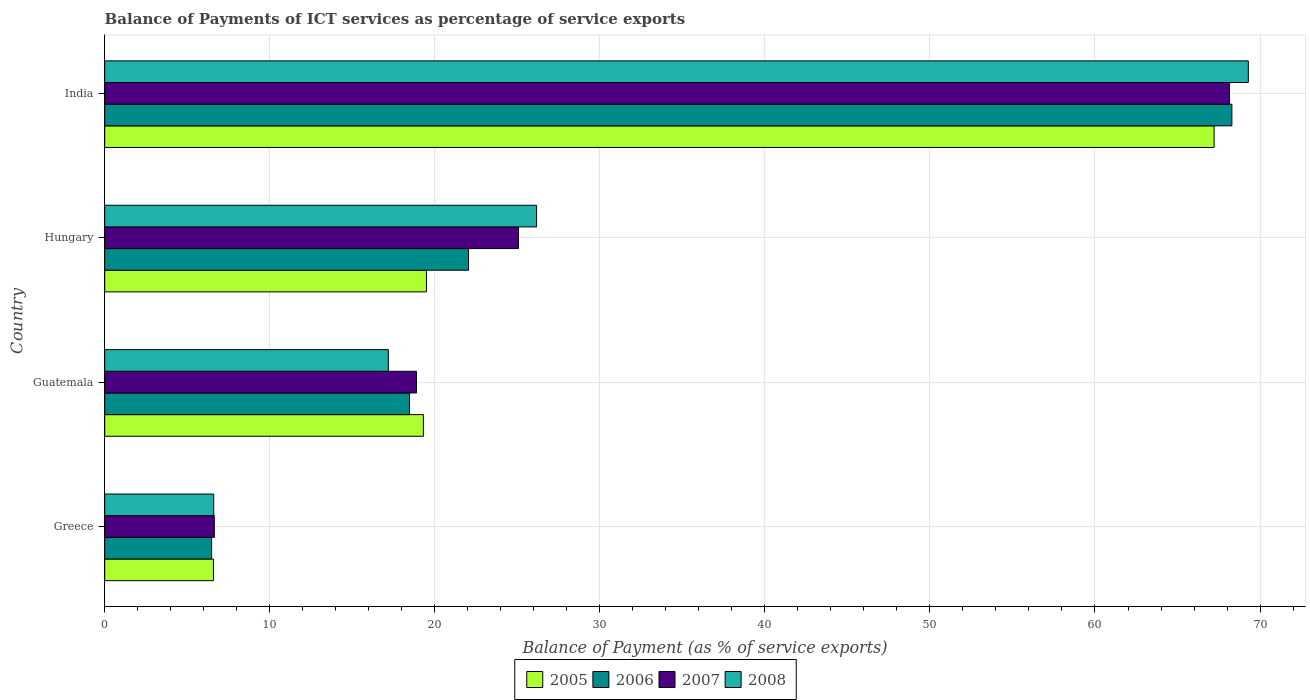How many different coloured bars are there?
Your answer should be very brief. 4. How many groups of bars are there?
Give a very brief answer. 4. Are the number of bars on each tick of the Y-axis equal?
Offer a terse response. Yes. How many bars are there on the 1st tick from the bottom?
Provide a short and direct response. 4. What is the label of the 2nd group of bars from the top?
Offer a terse response. Hungary. In how many cases, is the number of bars for a given country not equal to the number of legend labels?
Offer a terse response. 0. What is the balance of payments of ICT services in 2006 in India?
Give a very brief answer. 68.29. Across all countries, what is the maximum balance of payments of ICT services in 2005?
Offer a very short reply. 67.22. Across all countries, what is the minimum balance of payments of ICT services in 2005?
Keep it short and to the point. 6.59. In which country was the balance of payments of ICT services in 2005 maximum?
Provide a short and direct response. India. In which country was the balance of payments of ICT services in 2007 minimum?
Provide a succinct answer. Greece. What is the total balance of payments of ICT services in 2008 in the graph?
Offer a terse response. 119.24. What is the difference between the balance of payments of ICT services in 2008 in Guatemala and that in Hungary?
Give a very brief answer. -8.98. What is the difference between the balance of payments of ICT services in 2008 in India and the balance of payments of ICT services in 2007 in Hungary?
Your answer should be very brief. 44.22. What is the average balance of payments of ICT services in 2005 per country?
Your answer should be compact. 28.15. What is the difference between the balance of payments of ICT services in 2008 and balance of payments of ICT services in 2006 in Greece?
Your response must be concise. 0.13. In how many countries, is the balance of payments of ICT services in 2005 greater than 12 %?
Provide a succinct answer. 3. What is the ratio of the balance of payments of ICT services in 2007 in Greece to that in Guatemala?
Your response must be concise. 0.35. Is the balance of payments of ICT services in 2008 in Greece less than that in Hungary?
Your answer should be very brief. Yes. Is the difference between the balance of payments of ICT services in 2008 in Greece and Guatemala greater than the difference between the balance of payments of ICT services in 2006 in Greece and Guatemala?
Your response must be concise. Yes. What is the difference between the highest and the second highest balance of payments of ICT services in 2008?
Your answer should be very brief. 43.12. What is the difference between the highest and the lowest balance of payments of ICT services in 2008?
Ensure brevity in your answer.  62.69. Is it the case that in every country, the sum of the balance of payments of ICT services in 2007 and balance of payments of ICT services in 2006 is greater than the sum of balance of payments of ICT services in 2008 and balance of payments of ICT services in 2005?
Provide a short and direct response. No. What does the 4th bar from the bottom in Greece represents?
Your answer should be compact. 2008. Is it the case that in every country, the sum of the balance of payments of ICT services in 2006 and balance of payments of ICT services in 2008 is greater than the balance of payments of ICT services in 2005?
Your answer should be compact. Yes. How many countries are there in the graph?
Your response must be concise. 4. Are the values on the major ticks of X-axis written in scientific E-notation?
Offer a very short reply. No. Does the graph contain grids?
Offer a terse response. Yes. How are the legend labels stacked?
Ensure brevity in your answer.  Horizontal. What is the title of the graph?
Give a very brief answer. Balance of Payments of ICT services as percentage of service exports. What is the label or title of the X-axis?
Your answer should be compact. Balance of Payment (as % of service exports). What is the label or title of the Y-axis?
Keep it short and to the point. Country. What is the Balance of Payment (as % of service exports) in 2005 in Greece?
Give a very brief answer. 6.59. What is the Balance of Payment (as % of service exports) of 2006 in Greece?
Give a very brief answer. 6.48. What is the Balance of Payment (as % of service exports) of 2007 in Greece?
Ensure brevity in your answer.  6.64. What is the Balance of Payment (as % of service exports) in 2008 in Greece?
Provide a short and direct response. 6.6. What is the Balance of Payment (as % of service exports) in 2005 in Guatemala?
Provide a short and direct response. 19.31. What is the Balance of Payment (as % of service exports) in 2006 in Guatemala?
Your response must be concise. 18.47. What is the Balance of Payment (as % of service exports) of 2007 in Guatemala?
Make the answer very short. 18.89. What is the Balance of Payment (as % of service exports) of 2008 in Guatemala?
Offer a terse response. 17.18. What is the Balance of Payment (as % of service exports) of 2005 in Hungary?
Your response must be concise. 19.5. What is the Balance of Payment (as % of service exports) in 2006 in Hungary?
Ensure brevity in your answer.  22.04. What is the Balance of Payment (as % of service exports) in 2007 in Hungary?
Keep it short and to the point. 25.07. What is the Balance of Payment (as % of service exports) in 2008 in Hungary?
Keep it short and to the point. 26.17. What is the Balance of Payment (as % of service exports) of 2005 in India?
Provide a short and direct response. 67.22. What is the Balance of Payment (as % of service exports) of 2006 in India?
Your answer should be very brief. 68.29. What is the Balance of Payment (as % of service exports) of 2007 in India?
Give a very brief answer. 68.15. What is the Balance of Payment (as % of service exports) in 2008 in India?
Your answer should be very brief. 69.29. Across all countries, what is the maximum Balance of Payment (as % of service exports) in 2005?
Your answer should be very brief. 67.22. Across all countries, what is the maximum Balance of Payment (as % of service exports) in 2006?
Provide a succinct answer. 68.29. Across all countries, what is the maximum Balance of Payment (as % of service exports) in 2007?
Give a very brief answer. 68.15. Across all countries, what is the maximum Balance of Payment (as % of service exports) of 2008?
Offer a terse response. 69.29. Across all countries, what is the minimum Balance of Payment (as % of service exports) of 2005?
Give a very brief answer. 6.59. Across all countries, what is the minimum Balance of Payment (as % of service exports) of 2006?
Offer a terse response. 6.48. Across all countries, what is the minimum Balance of Payment (as % of service exports) in 2007?
Give a very brief answer. 6.64. Across all countries, what is the minimum Balance of Payment (as % of service exports) in 2008?
Provide a succinct answer. 6.6. What is the total Balance of Payment (as % of service exports) of 2005 in the graph?
Offer a very short reply. 112.61. What is the total Balance of Payment (as % of service exports) of 2006 in the graph?
Your response must be concise. 115.28. What is the total Balance of Payment (as % of service exports) in 2007 in the graph?
Your answer should be very brief. 118.75. What is the total Balance of Payment (as % of service exports) in 2008 in the graph?
Make the answer very short. 119.24. What is the difference between the Balance of Payment (as % of service exports) in 2005 in Greece and that in Guatemala?
Offer a very short reply. -12.72. What is the difference between the Balance of Payment (as % of service exports) in 2006 in Greece and that in Guatemala?
Provide a short and direct response. -11.99. What is the difference between the Balance of Payment (as % of service exports) in 2007 in Greece and that in Guatemala?
Your response must be concise. -12.25. What is the difference between the Balance of Payment (as % of service exports) in 2008 in Greece and that in Guatemala?
Your answer should be very brief. -10.58. What is the difference between the Balance of Payment (as % of service exports) in 2005 in Greece and that in Hungary?
Your response must be concise. -12.91. What is the difference between the Balance of Payment (as % of service exports) in 2006 in Greece and that in Hungary?
Make the answer very short. -15.57. What is the difference between the Balance of Payment (as % of service exports) in 2007 in Greece and that in Hungary?
Provide a succinct answer. -18.43. What is the difference between the Balance of Payment (as % of service exports) of 2008 in Greece and that in Hungary?
Your answer should be compact. -19.56. What is the difference between the Balance of Payment (as % of service exports) in 2005 in Greece and that in India?
Give a very brief answer. -60.63. What is the difference between the Balance of Payment (as % of service exports) of 2006 in Greece and that in India?
Make the answer very short. -61.82. What is the difference between the Balance of Payment (as % of service exports) of 2007 in Greece and that in India?
Your answer should be compact. -61.51. What is the difference between the Balance of Payment (as % of service exports) in 2008 in Greece and that in India?
Your response must be concise. -62.69. What is the difference between the Balance of Payment (as % of service exports) in 2005 in Guatemala and that in Hungary?
Keep it short and to the point. -0.19. What is the difference between the Balance of Payment (as % of service exports) of 2006 in Guatemala and that in Hungary?
Your answer should be very brief. -3.57. What is the difference between the Balance of Payment (as % of service exports) in 2007 in Guatemala and that in Hungary?
Offer a very short reply. -6.18. What is the difference between the Balance of Payment (as % of service exports) in 2008 in Guatemala and that in Hungary?
Offer a terse response. -8.98. What is the difference between the Balance of Payment (as % of service exports) of 2005 in Guatemala and that in India?
Your answer should be very brief. -47.91. What is the difference between the Balance of Payment (as % of service exports) in 2006 in Guatemala and that in India?
Make the answer very short. -49.83. What is the difference between the Balance of Payment (as % of service exports) of 2007 in Guatemala and that in India?
Your response must be concise. -49.26. What is the difference between the Balance of Payment (as % of service exports) of 2008 in Guatemala and that in India?
Make the answer very short. -52.11. What is the difference between the Balance of Payment (as % of service exports) of 2005 in Hungary and that in India?
Offer a very short reply. -47.72. What is the difference between the Balance of Payment (as % of service exports) of 2006 in Hungary and that in India?
Offer a very short reply. -46.25. What is the difference between the Balance of Payment (as % of service exports) of 2007 in Hungary and that in India?
Offer a very short reply. -43.08. What is the difference between the Balance of Payment (as % of service exports) in 2008 in Hungary and that in India?
Your answer should be compact. -43.12. What is the difference between the Balance of Payment (as % of service exports) in 2005 in Greece and the Balance of Payment (as % of service exports) in 2006 in Guatemala?
Provide a short and direct response. -11.88. What is the difference between the Balance of Payment (as % of service exports) of 2005 in Greece and the Balance of Payment (as % of service exports) of 2007 in Guatemala?
Provide a succinct answer. -12.3. What is the difference between the Balance of Payment (as % of service exports) in 2005 in Greece and the Balance of Payment (as % of service exports) in 2008 in Guatemala?
Provide a succinct answer. -10.6. What is the difference between the Balance of Payment (as % of service exports) in 2006 in Greece and the Balance of Payment (as % of service exports) in 2007 in Guatemala?
Provide a succinct answer. -12.41. What is the difference between the Balance of Payment (as % of service exports) of 2006 in Greece and the Balance of Payment (as % of service exports) of 2008 in Guatemala?
Keep it short and to the point. -10.71. What is the difference between the Balance of Payment (as % of service exports) of 2007 in Greece and the Balance of Payment (as % of service exports) of 2008 in Guatemala?
Your answer should be compact. -10.54. What is the difference between the Balance of Payment (as % of service exports) in 2005 in Greece and the Balance of Payment (as % of service exports) in 2006 in Hungary?
Your answer should be compact. -15.45. What is the difference between the Balance of Payment (as % of service exports) in 2005 in Greece and the Balance of Payment (as % of service exports) in 2007 in Hungary?
Give a very brief answer. -18.48. What is the difference between the Balance of Payment (as % of service exports) in 2005 in Greece and the Balance of Payment (as % of service exports) in 2008 in Hungary?
Your answer should be compact. -19.58. What is the difference between the Balance of Payment (as % of service exports) in 2006 in Greece and the Balance of Payment (as % of service exports) in 2007 in Hungary?
Give a very brief answer. -18.59. What is the difference between the Balance of Payment (as % of service exports) in 2006 in Greece and the Balance of Payment (as % of service exports) in 2008 in Hungary?
Your answer should be very brief. -19.69. What is the difference between the Balance of Payment (as % of service exports) in 2007 in Greece and the Balance of Payment (as % of service exports) in 2008 in Hungary?
Offer a terse response. -19.53. What is the difference between the Balance of Payment (as % of service exports) of 2005 in Greece and the Balance of Payment (as % of service exports) of 2006 in India?
Ensure brevity in your answer.  -61.71. What is the difference between the Balance of Payment (as % of service exports) in 2005 in Greece and the Balance of Payment (as % of service exports) in 2007 in India?
Offer a terse response. -61.56. What is the difference between the Balance of Payment (as % of service exports) in 2005 in Greece and the Balance of Payment (as % of service exports) in 2008 in India?
Ensure brevity in your answer.  -62.7. What is the difference between the Balance of Payment (as % of service exports) in 2006 in Greece and the Balance of Payment (as % of service exports) in 2007 in India?
Offer a terse response. -61.67. What is the difference between the Balance of Payment (as % of service exports) of 2006 in Greece and the Balance of Payment (as % of service exports) of 2008 in India?
Make the answer very short. -62.81. What is the difference between the Balance of Payment (as % of service exports) of 2007 in Greece and the Balance of Payment (as % of service exports) of 2008 in India?
Your answer should be compact. -62.65. What is the difference between the Balance of Payment (as % of service exports) of 2005 in Guatemala and the Balance of Payment (as % of service exports) of 2006 in Hungary?
Give a very brief answer. -2.73. What is the difference between the Balance of Payment (as % of service exports) of 2005 in Guatemala and the Balance of Payment (as % of service exports) of 2007 in Hungary?
Provide a succinct answer. -5.76. What is the difference between the Balance of Payment (as % of service exports) in 2005 in Guatemala and the Balance of Payment (as % of service exports) in 2008 in Hungary?
Provide a succinct answer. -6.86. What is the difference between the Balance of Payment (as % of service exports) of 2006 in Guatemala and the Balance of Payment (as % of service exports) of 2007 in Hungary?
Keep it short and to the point. -6.6. What is the difference between the Balance of Payment (as % of service exports) of 2006 in Guatemala and the Balance of Payment (as % of service exports) of 2008 in Hungary?
Your response must be concise. -7.7. What is the difference between the Balance of Payment (as % of service exports) in 2007 in Guatemala and the Balance of Payment (as % of service exports) in 2008 in Hungary?
Your response must be concise. -7.28. What is the difference between the Balance of Payment (as % of service exports) of 2005 in Guatemala and the Balance of Payment (as % of service exports) of 2006 in India?
Offer a very short reply. -48.99. What is the difference between the Balance of Payment (as % of service exports) of 2005 in Guatemala and the Balance of Payment (as % of service exports) of 2007 in India?
Ensure brevity in your answer.  -48.84. What is the difference between the Balance of Payment (as % of service exports) of 2005 in Guatemala and the Balance of Payment (as % of service exports) of 2008 in India?
Keep it short and to the point. -49.98. What is the difference between the Balance of Payment (as % of service exports) in 2006 in Guatemala and the Balance of Payment (as % of service exports) in 2007 in India?
Make the answer very short. -49.68. What is the difference between the Balance of Payment (as % of service exports) of 2006 in Guatemala and the Balance of Payment (as % of service exports) of 2008 in India?
Provide a succinct answer. -50.82. What is the difference between the Balance of Payment (as % of service exports) in 2007 in Guatemala and the Balance of Payment (as % of service exports) in 2008 in India?
Make the answer very short. -50.4. What is the difference between the Balance of Payment (as % of service exports) in 2005 in Hungary and the Balance of Payment (as % of service exports) in 2006 in India?
Your answer should be compact. -48.8. What is the difference between the Balance of Payment (as % of service exports) of 2005 in Hungary and the Balance of Payment (as % of service exports) of 2007 in India?
Provide a succinct answer. -48.65. What is the difference between the Balance of Payment (as % of service exports) in 2005 in Hungary and the Balance of Payment (as % of service exports) in 2008 in India?
Make the answer very short. -49.79. What is the difference between the Balance of Payment (as % of service exports) in 2006 in Hungary and the Balance of Payment (as % of service exports) in 2007 in India?
Your answer should be very brief. -46.11. What is the difference between the Balance of Payment (as % of service exports) in 2006 in Hungary and the Balance of Payment (as % of service exports) in 2008 in India?
Offer a very short reply. -47.25. What is the difference between the Balance of Payment (as % of service exports) in 2007 in Hungary and the Balance of Payment (as % of service exports) in 2008 in India?
Keep it short and to the point. -44.22. What is the average Balance of Payment (as % of service exports) in 2005 per country?
Your answer should be compact. 28.15. What is the average Balance of Payment (as % of service exports) in 2006 per country?
Ensure brevity in your answer.  28.82. What is the average Balance of Payment (as % of service exports) of 2007 per country?
Make the answer very short. 29.69. What is the average Balance of Payment (as % of service exports) in 2008 per country?
Keep it short and to the point. 29.81. What is the difference between the Balance of Payment (as % of service exports) of 2005 and Balance of Payment (as % of service exports) of 2006 in Greece?
Ensure brevity in your answer.  0.11. What is the difference between the Balance of Payment (as % of service exports) of 2005 and Balance of Payment (as % of service exports) of 2007 in Greece?
Make the answer very short. -0.05. What is the difference between the Balance of Payment (as % of service exports) in 2005 and Balance of Payment (as % of service exports) in 2008 in Greece?
Ensure brevity in your answer.  -0.02. What is the difference between the Balance of Payment (as % of service exports) in 2006 and Balance of Payment (as % of service exports) in 2007 in Greece?
Offer a terse response. -0.16. What is the difference between the Balance of Payment (as % of service exports) in 2006 and Balance of Payment (as % of service exports) in 2008 in Greece?
Make the answer very short. -0.13. What is the difference between the Balance of Payment (as % of service exports) in 2007 and Balance of Payment (as % of service exports) in 2008 in Greece?
Provide a short and direct response. 0.04. What is the difference between the Balance of Payment (as % of service exports) in 2005 and Balance of Payment (as % of service exports) in 2006 in Guatemala?
Keep it short and to the point. 0.84. What is the difference between the Balance of Payment (as % of service exports) in 2005 and Balance of Payment (as % of service exports) in 2007 in Guatemala?
Your answer should be very brief. 0.42. What is the difference between the Balance of Payment (as % of service exports) in 2005 and Balance of Payment (as % of service exports) in 2008 in Guatemala?
Make the answer very short. 2.12. What is the difference between the Balance of Payment (as % of service exports) of 2006 and Balance of Payment (as % of service exports) of 2007 in Guatemala?
Offer a very short reply. -0.42. What is the difference between the Balance of Payment (as % of service exports) of 2006 and Balance of Payment (as % of service exports) of 2008 in Guatemala?
Make the answer very short. 1.28. What is the difference between the Balance of Payment (as % of service exports) in 2007 and Balance of Payment (as % of service exports) in 2008 in Guatemala?
Give a very brief answer. 1.71. What is the difference between the Balance of Payment (as % of service exports) of 2005 and Balance of Payment (as % of service exports) of 2006 in Hungary?
Your answer should be compact. -2.55. What is the difference between the Balance of Payment (as % of service exports) of 2005 and Balance of Payment (as % of service exports) of 2007 in Hungary?
Your answer should be very brief. -5.57. What is the difference between the Balance of Payment (as % of service exports) in 2005 and Balance of Payment (as % of service exports) in 2008 in Hungary?
Your response must be concise. -6.67. What is the difference between the Balance of Payment (as % of service exports) in 2006 and Balance of Payment (as % of service exports) in 2007 in Hungary?
Offer a terse response. -3.03. What is the difference between the Balance of Payment (as % of service exports) of 2006 and Balance of Payment (as % of service exports) of 2008 in Hungary?
Keep it short and to the point. -4.13. What is the difference between the Balance of Payment (as % of service exports) in 2007 and Balance of Payment (as % of service exports) in 2008 in Hungary?
Your answer should be compact. -1.1. What is the difference between the Balance of Payment (as % of service exports) in 2005 and Balance of Payment (as % of service exports) in 2006 in India?
Keep it short and to the point. -1.08. What is the difference between the Balance of Payment (as % of service exports) in 2005 and Balance of Payment (as % of service exports) in 2007 in India?
Keep it short and to the point. -0.93. What is the difference between the Balance of Payment (as % of service exports) in 2005 and Balance of Payment (as % of service exports) in 2008 in India?
Give a very brief answer. -2.07. What is the difference between the Balance of Payment (as % of service exports) in 2006 and Balance of Payment (as % of service exports) in 2007 in India?
Make the answer very short. 0.15. What is the difference between the Balance of Payment (as % of service exports) of 2006 and Balance of Payment (as % of service exports) of 2008 in India?
Offer a terse response. -0.99. What is the difference between the Balance of Payment (as % of service exports) in 2007 and Balance of Payment (as % of service exports) in 2008 in India?
Give a very brief answer. -1.14. What is the ratio of the Balance of Payment (as % of service exports) of 2005 in Greece to that in Guatemala?
Give a very brief answer. 0.34. What is the ratio of the Balance of Payment (as % of service exports) of 2006 in Greece to that in Guatemala?
Keep it short and to the point. 0.35. What is the ratio of the Balance of Payment (as % of service exports) in 2007 in Greece to that in Guatemala?
Keep it short and to the point. 0.35. What is the ratio of the Balance of Payment (as % of service exports) in 2008 in Greece to that in Guatemala?
Offer a very short reply. 0.38. What is the ratio of the Balance of Payment (as % of service exports) in 2005 in Greece to that in Hungary?
Offer a terse response. 0.34. What is the ratio of the Balance of Payment (as % of service exports) in 2006 in Greece to that in Hungary?
Your answer should be compact. 0.29. What is the ratio of the Balance of Payment (as % of service exports) in 2007 in Greece to that in Hungary?
Offer a terse response. 0.26. What is the ratio of the Balance of Payment (as % of service exports) of 2008 in Greece to that in Hungary?
Offer a very short reply. 0.25. What is the ratio of the Balance of Payment (as % of service exports) of 2005 in Greece to that in India?
Keep it short and to the point. 0.1. What is the ratio of the Balance of Payment (as % of service exports) of 2006 in Greece to that in India?
Provide a short and direct response. 0.09. What is the ratio of the Balance of Payment (as % of service exports) of 2007 in Greece to that in India?
Your answer should be compact. 0.1. What is the ratio of the Balance of Payment (as % of service exports) of 2008 in Greece to that in India?
Your response must be concise. 0.1. What is the ratio of the Balance of Payment (as % of service exports) in 2005 in Guatemala to that in Hungary?
Ensure brevity in your answer.  0.99. What is the ratio of the Balance of Payment (as % of service exports) of 2006 in Guatemala to that in Hungary?
Make the answer very short. 0.84. What is the ratio of the Balance of Payment (as % of service exports) in 2007 in Guatemala to that in Hungary?
Provide a succinct answer. 0.75. What is the ratio of the Balance of Payment (as % of service exports) in 2008 in Guatemala to that in Hungary?
Give a very brief answer. 0.66. What is the ratio of the Balance of Payment (as % of service exports) of 2005 in Guatemala to that in India?
Your response must be concise. 0.29. What is the ratio of the Balance of Payment (as % of service exports) in 2006 in Guatemala to that in India?
Provide a succinct answer. 0.27. What is the ratio of the Balance of Payment (as % of service exports) in 2007 in Guatemala to that in India?
Ensure brevity in your answer.  0.28. What is the ratio of the Balance of Payment (as % of service exports) in 2008 in Guatemala to that in India?
Offer a very short reply. 0.25. What is the ratio of the Balance of Payment (as % of service exports) in 2005 in Hungary to that in India?
Your answer should be compact. 0.29. What is the ratio of the Balance of Payment (as % of service exports) in 2006 in Hungary to that in India?
Keep it short and to the point. 0.32. What is the ratio of the Balance of Payment (as % of service exports) of 2007 in Hungary to that in India?
Your answer should be compact. 0.37. What is the ratio of the Balance of Payment (as % of service exports) in 2008 in Hungary to that in India?
Your answer should be compact. 0.38. What is the difference between the highest and the second highest Balance of Payment (as % of service exports) of 2005?
Your response must be concise. 47.72. What is the difference between the highest and the second highest Balance of Payment (as % of service exports) in 2006?
Ensure brevity in your answer.  46.25. What is the difference between the highest and the second highest Balance of Payment (as % of service exports) of 2007?
Offer a very short reply. 43.08. What is the difference between the highest and the second highest Balance of Payment (as % of service exports) of 2008?
Keep it short and to the point. 43.12. What is the difference between the highest and the lowest Balance of Payment (as % of service exports) in 2005?
Keep it short and to the point. 60.63. What is the difference between the highest and the lowest Balance of Payment (as % of service exports) of 2006?
Your response must be concise. 61.82. What is the difference between the highest and the lowest Balance of Payment (as % of service exports) in 2007?
Your answer should be compact. 61.51. What is the difference between the highest and the lowest Balance of Payment (as % of service exports) in 2008?
Provide a succinct answer. 62.69. 